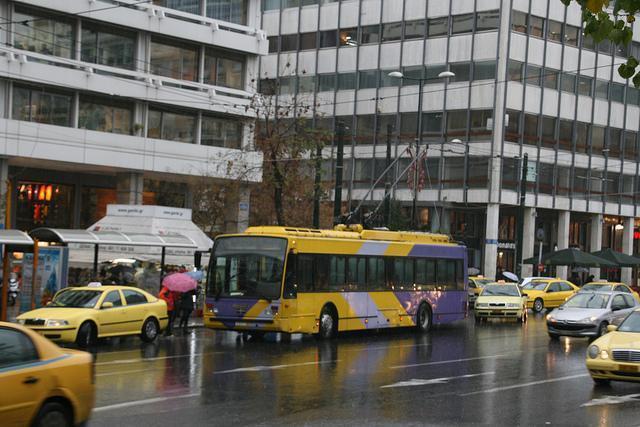How many cars are in the photo?
Give a very brief answer. 5. 